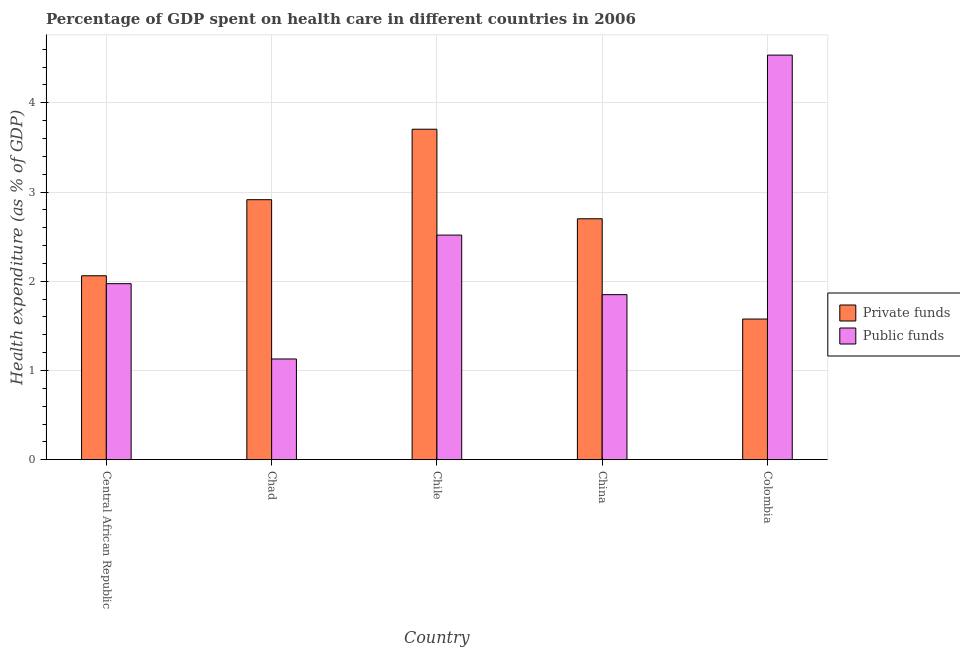How many groups of bars are there?
Make the answer very short. 5. Are the number of bars per tick equal to the number of legend labels?
Keep it short and to the point. Yes. Are the number of bars on each tick of the X-axis equal?
Ensure brevity in your answer.  Yes. How many bars are there on the 2nd tick from the left?
Keep it short and to the point. 2. In how many cases, is the number of bars for a given country not equal to the number of legend labels?
Make the answer very short. 0. What is the amount of public funds spent in healthcare in Central African Republic?
Provide a succinct answer. 1.97. Across all countries, what is the maximum amount of private funds spent in healthcare?
Your answer should be very brief. 3.7. Across all countries, what is the minimum amount of private funds spent in healthcare?
Provide a succinct answer. 1.58. In which country was the amount of public funds spent in healthcare maximum?
Ensure brevity in your answer.  Colombia. In which country was the amount of public funds spent in healthcare minimum?
Your answer should be compact. Chad. What is the total amount of private funds spent in healthcare in the graph?
Offer a very short reply. 12.96. What is the difference between the amount of public funds spent in healthcare in Chile and that in China?
Offer a terse response. 0.67. What is the difference between the amount of private funds spent in healthcare in Chad and the amount of public funds spent in healthcare in Central African Republic?
Your answer should be compact. 0.94. What is the average amount of public funds spent in healthcare per country?
Provide a short and direct response. 2.4. What is the difference between the amount of private funds spent in healthcare and amount of public funds spent in healthcare in Chile?
Make the answer very short. 1.19. What is the ratio of the amount of private funds spent in healthcare in Chad to that in Colombia?
Provide a short and direct response. 1.85. Is the amount of public funds spent in healthcare in Chile less than that in China?
Ensure brevity in your answer.  No. Is the difference between the amount of private funds spent in healthcare in Central African Republic and Chile greater than the difference between the amount of public funds spent in healthcare in Central African Republic and Chile?
Your response must be concise. No. What is the difference between the highest and the second highest amount of public funds spent in healthcare?
Give a very brief answer. 2.02. What is the difference between the highest and the lowest amount of private funds spent in healthcare?
Make the answer very short. 2.13. In how many countries, is the amount of private funds spent in healthcare greater than the average amount of private funds spent in healthcare taken over all countries?
Offer a terse response. 3. Is the sum of the amount of private funds spent in healthcare in Chad and Chile greater than the maximum amount of public funds spent in healthcare across all countries?
Ensure brevity in your answer.  Yes. What does the 2nd bar from the left in Chad represents?
Provide a short and direct response. Public funds. What does the 1st bar from the right in Colombia represents?
Keep it short and to the point. Public funds. How many bars are there?
Ensure brevity in your answer.  10. What is the difference between two consecutive major ticks on the Y-axis?
Provide a short and direct response. 1. Are the values on the major ticks of Y-axis written in scientific E-notation?
Offer a very short reply. No. Does the graph contain any zero values?
Give a very brief answer. No. Where does the legend appear in the graph?
Offer a terse response. Center right. What is the title of the graph?
Make the answer very short. Percentage of GDP spent on health care in different countries in 2006. Does "IMF concessional" appear as one of the legend labels in the graph?
Your answer should be compact. No. What is the label or title of the Y-axis?
Offer a very short reply. Health expenditure (as % of GDP). What is the Health expenditure (as % of GDP) of Private funds in Central African Republic?
Offer a very short reply. 2.06. What is the Health expenditure (as % of GDP) of Public funds in Central African Republic?
Give a very brief answer. 1.97. What is the Health expenditure (as % of GDP) of Private funds in Chad?
Provide a short and direct response. 2.91. What is the Health expenditure (as % of GDP) in Public funds in Chad?
Provide a succinct answer. 1.13. What is the Health expenditure (as % of GDP) in Private funds in Chile?
Make the answer very short. 3.7. What is the Health expenditure (as % of GDP) in Public funds in Chile?
Provide a short and direct response. 2.52. What is the Health expenditure (as % of GDP) of Private funds in China?
Give a very brief answer. 2.7. What is the Health expenditure (as % of GDP) in Public funds in China?
Ensure brevity in your answer.  1.85. What is the Health expenditure (as % of GDP) of Private funds in Colombia?
Your answer should be compact. 1.58. What is the Health expenditure (as % of GDP) in Public funds in Colombia?
Your answer should be very brief. 4.54. Across all countries, what is the maximum Health expenditure (as % of GDP) in Private funds?
Offer a very short reply. 3.7. Across all countries, what is the maximum Health expenditure (as % of GDP) of Public funds?
Give a very brief answer. 4.54. Across all countries, what is the minimum Health expenditure (as % of GDP) of Private funds?
Give a very brief answer. 1.58. Across all countries, what is the minimum Health expenditure (as % of GDP) of Public funds?
Provide a succinct answer. 1.13. What is the total Health expenditure (as % of GDP) in Private funds in the graph?
Make the answer very short. 12.96. What is the total Health expenditure (as % of GDP) of Public funds in the graph?
Offer a very short reply. 12. What is the difference between the Health expenditure (as % of GDP) in Private funds in Central African Republic and that in Chad?
Provide a succinct answer. -0.85. What is the difference between the Health expenditure (as % of GDP) in Public funds in Central African Republic and that in Chad?
Your answer should be very brief. 0.84. What is the difference between the Health expenditure (as % of GDP) in Private funds in Central African Republic and that in Chile?
Provide a short and direct response. -1.64. What is the difference between the Health expenditure (as % of GDP) of Public funds in Central African Republic and that in Chile?
Make the answer very short. -0.54. What is the difference between the Health expenditure (as % of GDP) of Private funds in Central African Republic and that in China?
Give a very brief answer. -0.64. What is the difference between the Health expenditure (as % of GDP) in Public funds in Central African Republic and that in China?
Ensure brevity in your answer.  0.12. What is the difference between the Health expenditure (as % of GDP) in Private funds in Central African Republic and that in Colombia?
Make the answer very short. 0.48. What is the difference between the Health expenditure (as % of GDP) in Public funds in Central African Republic and that in Colombia?
Provide a succinct answer. -2.56. What is the difference between the Health expenditure (as % of GDP) of Private funds in Chad and that in Chile?
Keep it short and to the point. -0.79. What is the difference between the Health expenditure (as % of GDP) of Public funds in Chad and that in Chile?
Provide a succinct answer. -1.39. What is the difference between the Health expenditure (as % of GDP) in Private funds in Chad and that in China?
Keep it short and to the point. 0.21. What is the difference between the Health expenditure (as % of GDP) of Public funds in Chad and that in China?
Make the answer very short. -0.72. What is the difference between the Health expenditure (as % of GDP) in Private funds in Chad and that in Colombia?
Offer a terse response. 1.34. What is the difference between the Health expenditure (as % of GDP) of Public funds in Chad and that in Colombia?
Offer a very short reply. -3.41. What is the difference between the Health expenditure (as % of GDP) in Private funds in Chile and that in China?
Your answer should be very brief. 1. What is the difference between the Health expenditure (as % of GDP) of Public funds in Chile and that in China?
Make the answer very short. 0.67. What is the difference between the Health expenditure (as % of GDP) of Private funds in Chile and that in Colombia?
Provide a short and direct response. 2.13. What is the difference between the Health expenditure (as % of GDP) in Public funds in Chile and that in Colombia?
Offer a terse response. -2.02. What is the difference between the Health expenditure (as % of GDP) in Private funds in China and that in Colombia?
Offer a terse response. 1.12. What is the difference between the Health expenditure (as % of GDP) of Public funds in China and that in Colombia?
Your response must be concise. -2.69. What is the difference between the Health expenditure (as % of GDP) of Private funds in Central African Republic and the Health expenditure (as % of GDP) of Public funds in Chad?
Provide a short and direct response. 0.93. What is the difference between the Health expenditure (as % of GDP) of Private funds in Central African Republic and the Health expenditure (as % of GDP) of Public funds in Chile?
Offer a terse response. -0.46. What is the difference between the Health expenditure (as % of GDP) in Private funds in Central African Republic and the Health expenditure (as % of GDP) in Public funds in China?
Provide a short and direct response. 0.21. What is the difference between the Health expenditure (as % of GDP) in Private funds in Central African Republic and the Health expenditure (as % of GDP) in Public funds in Colombia?
Provide a succinct answer. -2.47. What is the difference between the Health expenditure (as % of GDP) of Private funds in Chad and the Health expenditure (as % of GDP) of Public funds in Chile?
Give a very brief answer. 0.4. What is the difference between the Health expenditure (as % of GDP) of Private funds in Chad and the Health expenditure (as % of GDP) of Public funds in China?
Your response must be concise. 1.06. What is the difference between the Health expenditure (as % of GDP) in Private funds in Chad and the Health expenditure (as % of GDP) in Public funds in Colombia?
Your answer should be compact. -1.62. What is the difference between the Health expenditure (as % of GDP) of Private funds in Chile and the Health expenditure (as % of GDP) of Public funds in China?
Ensure brevity in your answer.  1.85. What is the difference between the Health expenditure (as % of GDP) in Private funds in Chile and the Health expenditure (as % of GDP) in Public funds in Colombia?
Provide a short and direct response. -0.83. What is the difference between the Health expenditure (as % of GDP) of Private funds in China and the Health expenditure (as % of GDP) of Public funds in Colombia?
Give a very brief answer. -1.83. What is the average Health expenditure (as % of GDP) of Private funds per country?
Give a very brief answer. 2.59. What is the average Health expenditure (as % of GDP) of Public funds per country?
Provide a short and direct response. 2.4. What is the difference between the Health expenditure (as % of GDP) in Private funds and Health expenditure (as % of GDP) in Public funds in Central African Republic?
Keep it short and to the point. 0.09. What is the difference between the Health expenditure (as % of GDP) of Private funds and Health expenditure (as % of GDP) of Public funds in Chad?
Offer a very short reply. 1.79. What is the difference between the Health expenditure (as % of GDP) of Private funds and Health expenditure (as % of GDP) of Public funds in Chile?
Make the answer very short. 1.19. What is the difference between the Health expenditure (as % of GDP) in Private funds and Health expenditure (as % of GDP) in Public funds in China?
Offer a terse response. 0.85. What is the difference between the Health expenditure (as % of GDP) in Private funds and Health expenditure (as % of GDP) in Public funds in Colombia?
Provide a succinct answer. -2.96. What is the ratio of the Health expenditure (as % of GDP) of Private funds in Central African Republic to that in Chad?
Your response must be concise. 0.71. What is the ratio of the Health expenditure (as % of GDP) in Public funds in Central African Republic to that in Chad?
Provide a succinct answer. 1.75. What is the ratio of the Health expenditure (as % of GDP) of Private funds in Central African Republic to that in Chile?
Make the answer very short. 0.56. What is the ratio of the Health expenditure (as % of GDP) in Public funds in Central African Republic to that in Chile?
Make the answer very short. 0.78. What is the ratio of the Health expenditure (as % of GDP) of Private funds in Central African Republic to that in China?
Keep it short and to the point. 0.76. What is the ratio of the Health expenditure (as % of GDP) in Public funds in Central African Republic to that in China?
Your response must be concise. 1.07. What is the ratio of the Health expenditure (as % of GDP) in Private funds in Central African Republic to that in Colombia?
Ensure brevity in your answer.  1.31. What is the ratio of the Health expenditure (as % of GDP) of Public funds in Central African Republic to that in Colombia?
Your answer should be very brief. 0.44. What is the ratio of the Health expenditure (as % of GDP) in Private funds in Chad to that in Chile?
Provide a short and direct response. 0.79. What is the ratio of the Health expenditure (as % of GDP) of Public funds in Chad to that in Chile?
Ensure brevity in your answer.  0.45. What is the ratio of the Health expenditure (as % of GDP) in Private funds in Chad to that in China?
Ensure brevity in your answer.  1.08. What is the ratio of the Health expenditure (as % of GDP) in Public funds in Chad to that in China?
Provide a short and direct response. 0.61. What is the ratio of the Health expenditure (as % of GDP) in Private funds in Chad to that in Colombia?
Ensure brevity in your answer.  1.85. What is the ratio of the Health expenditure (as % of GDP) of Public funds in Chad to that in Colombia?
Your answer should be compact. 0.25. What is the ratio of the Health expenditure (as % of GDP) in Private funds in Chile to that in China?
Give a very brief answer. 1.37. What is the ratio of the Health expenditure (as % of GDP) of Public funds in Chile to that in China?
Make the answer very short. 1.36. What is the ratio of the Health expenditure (as % of GDP) of Private funds in Chile to that in Colombia?
Keep it short and to the point. 2.35. What is the ratio of the Health expenditure (as % of GDP) of Public funds in Chile to that in Colombia?
Your answer should be very brief. 0.56. What is the ratio of the Health expenditure (as % of GDP) in Private funds in China to that in Colombia?
Offer a terse response. 1.71. What is the ratio of the Health expenditure (as % of GDP) of Public funds in China to that in Colombia?
Offer a terse response. 0.41. What is the difference between the highest and the second highest Health expenditure (as % of GDP) in Private funds?
Keep it short and to the point. 0.79. What is the difference between the highest and the second highest Health expenditure (as % of GDP) in Public funds?
Keep it short and to the point. 2.02. What is the difference between the highest and the lowest Health expenditure (as % of GDP) of Private funds?
Ensure brevity in your answer.  2.13. What is the difference between the highest and the lowest Health expenditure (as % of GDP) in Public funds?
Make the answer very short. 3.41. 